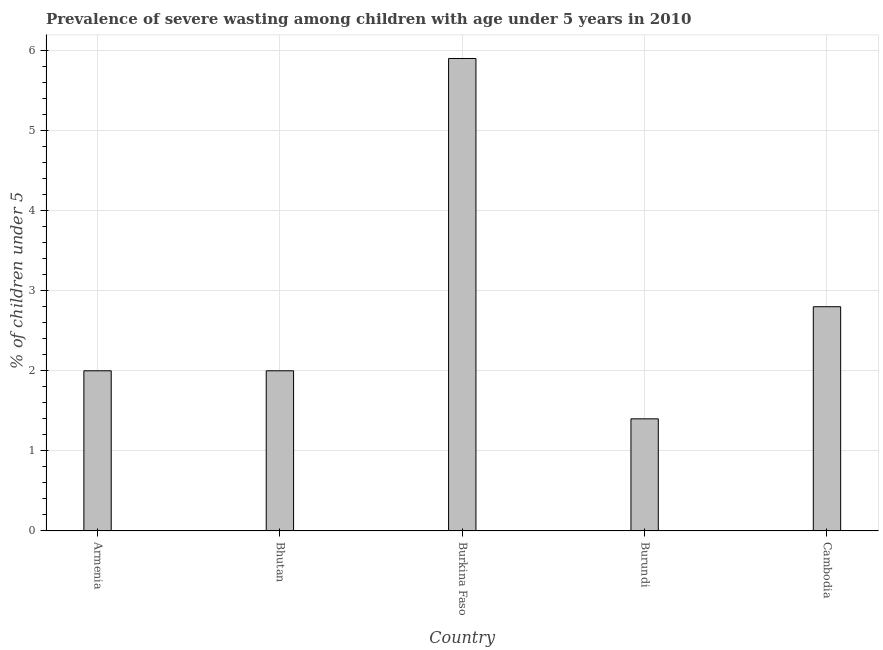Does the graph contain grids?
Your response must be concise. Yes. What is the title of the graph?
Give a very brief answer. Prevalence of severe wasting among children with age under 5 years in 2010. What is the label or title of the X-axis?
Provide a short and direct response. Country. What is the label or title of the Y-axis?
Offer a very short reply.  % of children under 5. What is the prevalence of severe wasting in Cambodia?
Provide a succinct answer. 2.8. Across all countries, what is the maximum prevalence of severe wasting?
Offer a terse response. 5.9. Across all countries, what is the minimum prevalence of severe wasting?
Make the answer very short. 1.4. In which country was the prevalence of severe wasting maximum?
Your answer should be compact. Burkina Faso. In which country was the prevalence of severe wasting minimum?
Offer a very short reply. Burundi. What is the sum of the prevalence of severe wasting?
Offer a terse response. 14.1. What is the average prevalence of severe wasting per country?
Provide a short and direct response. 2.82. What is the median prevalence of severe wasting?
Give a very brief answer. 2. What is the ratio of the prevalence of severe wasting in Armenia to that in Cambodia?
Your answer should be very brief. 0.71. Is the difference between the prevalence of severe wasting in Bhutan and Cambodia greater than the difference between any two countries?
Your answer should be very brief. No. What is the difference between the highest and the second highest prevalence of severe wasting?
Your response must be concise. 3.1. Is the sum of the prevalence of severe wasting in Burkina Faso and Burundi greater than the maximum prevalence of severe wasting across all countries?
Your response must be concise. Yes. What is the difference between the highest and the lowest prevalence of severe wasting?
Keep it short and to the point. 4.5. How many bars are there?
Provide a succinct answer. 5. How many countries are there in the graph?
Provide a short and direct response. 5. What is the difference between two consecutive major ticks on the Y-axis?
Your response must be concise. 1. Are the values on the major ticks of Y-axis written in scientific E-notation?
Offer a very short reply. No. What is the  % of children under 5 of Armenia?
Your response must be concise. 2. What is the  % of children under 5 of Bhutan?
Offer a terse response. 2. What is the  % of children under 5 of Burkina Faso?
Give a very brief answer. 5.9. What is the  % of children under 5 in Burundi?
Provide a short and direct response. 1.4. What is the  % of children under 5 of Cambodia?
Offer a terse response. 2.8. What is the difference between the  % of children under 5 in Armenia and Bhutan?
Provide a short and direct response. 0. What is the difference between the  % of children under 5 in Armenia and Cambodia?
Provide a short and direct response. -0.8. What is the difference between the  % of children under 5 in Bhutan and Burkina Faso?
Ensure brevity in your answer.  -3.9. What is the difference between the  % of children under 5 in Bhutan and Burundi?
Ensure brevity in your answer.  0.6. What is the difference between the  % of children under 5 in Bhutan and Cambodia?
Your answer should be compact. -0.8. What is the difference between the  % of children under 5 in Burkina Faso and Cambodia?
Make the answer very short. 3.1. What is the difference between the  % of children under 5 in Burundi and Cambodia?
Your answer should be very brief. -1.4. What is the ratio of the  % of children under 5 in Armenia to that in Bhutan?
Make the answer very short. 1. What is the ratio of the  % of children under 5 in Armenia to that in Burkina Faso?
Offer a very short reply. 0.34. What is the ratio of the  % of children under 5 in Armenia to that in Burundi?
Provide a succinct answer. 1.43. What is the ratio of the  % of children under 5 in Armenia to that in Cambodia?
Your response must be concise. 0.71. What is the ratio of the  % of children under 5 in Bhutan to that in Burkina Faso?
Your answer should be very brief. 0.34. What is the ratio of the  % of children under 5 in Bhutan to that in Burundi?
Your answer should be very brief. 1.43. What is the ratio of the  % of children under 5 in Bhutan to that in Cambodia?
Make the answer very short. 0.71. What is the ratio of the  % of children under 5 in Burkina Faso to that in Burundi?
Your response must be concise. 4.21. What is the ratio of the  % of children under 5 in Burkina Faso to that in Cambodia?
Make the answer very short. 2.11. 